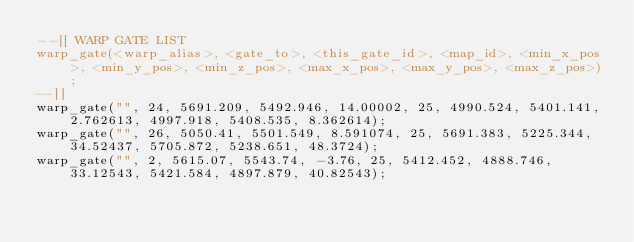Convert code to text. <code><loc_0><loc_0><loc_500><loc_500><_Lua_>--[[ WARP GATE LIST
warp_gate(<warp_alias>, <gate_to>, <this_gate_id>, <map_id>, <min_x_pos>, <min_y_pos>, <min_z_pos>, <max_x_pos>, <max_y_pos>, <max_z_pos>);
--]]
warp_gate("", 24, 5691.209, 5492.946, 14.00002, 25, 4990.524, 5401.141, 2.762613, 4997.918, 5408.535, 8.362614);
warp_gate("", 26, 5050.41, 5501.549, 8.591074, 25, 5691.383, 5225.344, 34.52437, 5705.872, 5238.651, 48.3724);
warp_gate("", 2, 5615.07, 5543.74, -3.76, 25, 5412.452, 4888.746, 33.12543, 5421.584, 4897.879, 40.82543);
</code> 